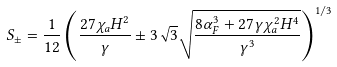<formula> <loc_0><loc_0><loc_500><loc_500>S _ { \pm } = \frac { 1 } { 1 2 } \left ( \frac { 2 7 \chi _ { a } H ^ { 2 } } { \gamma } \pm 3 \sqrt { 3 } \sqrt { \frac { 8 \alpha _ { F } ^ { 3 } + 2 7 \gamma \chi _ { a } ^ { 2 } H ^ { 4 } } { \gamma ^ { 3 } } } \right ) ^ { 1 / 3 }</formula> 